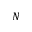Convert formula to latex. <formula><loc_0><loc_0><loc_500><loc_500>N</formula> 